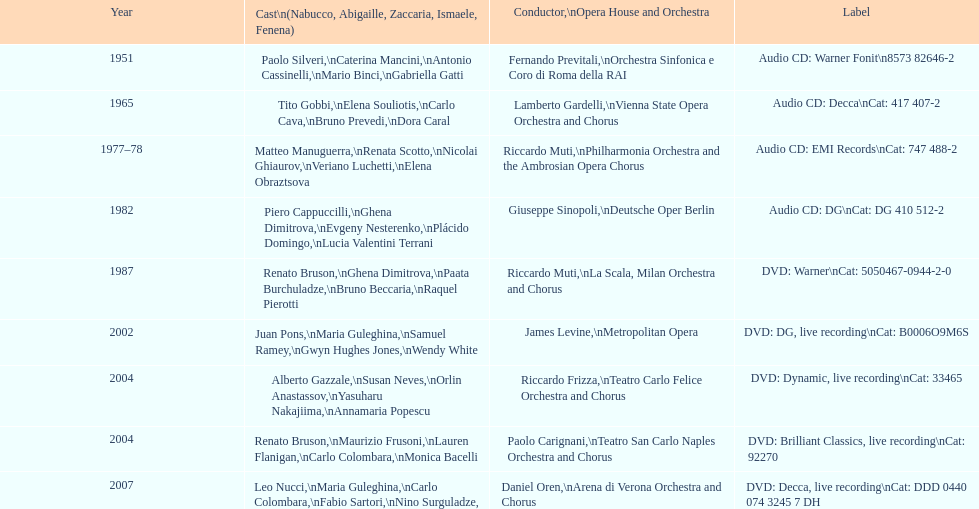When was the recording of nabucco made in the metropolitan opera? 2002. 